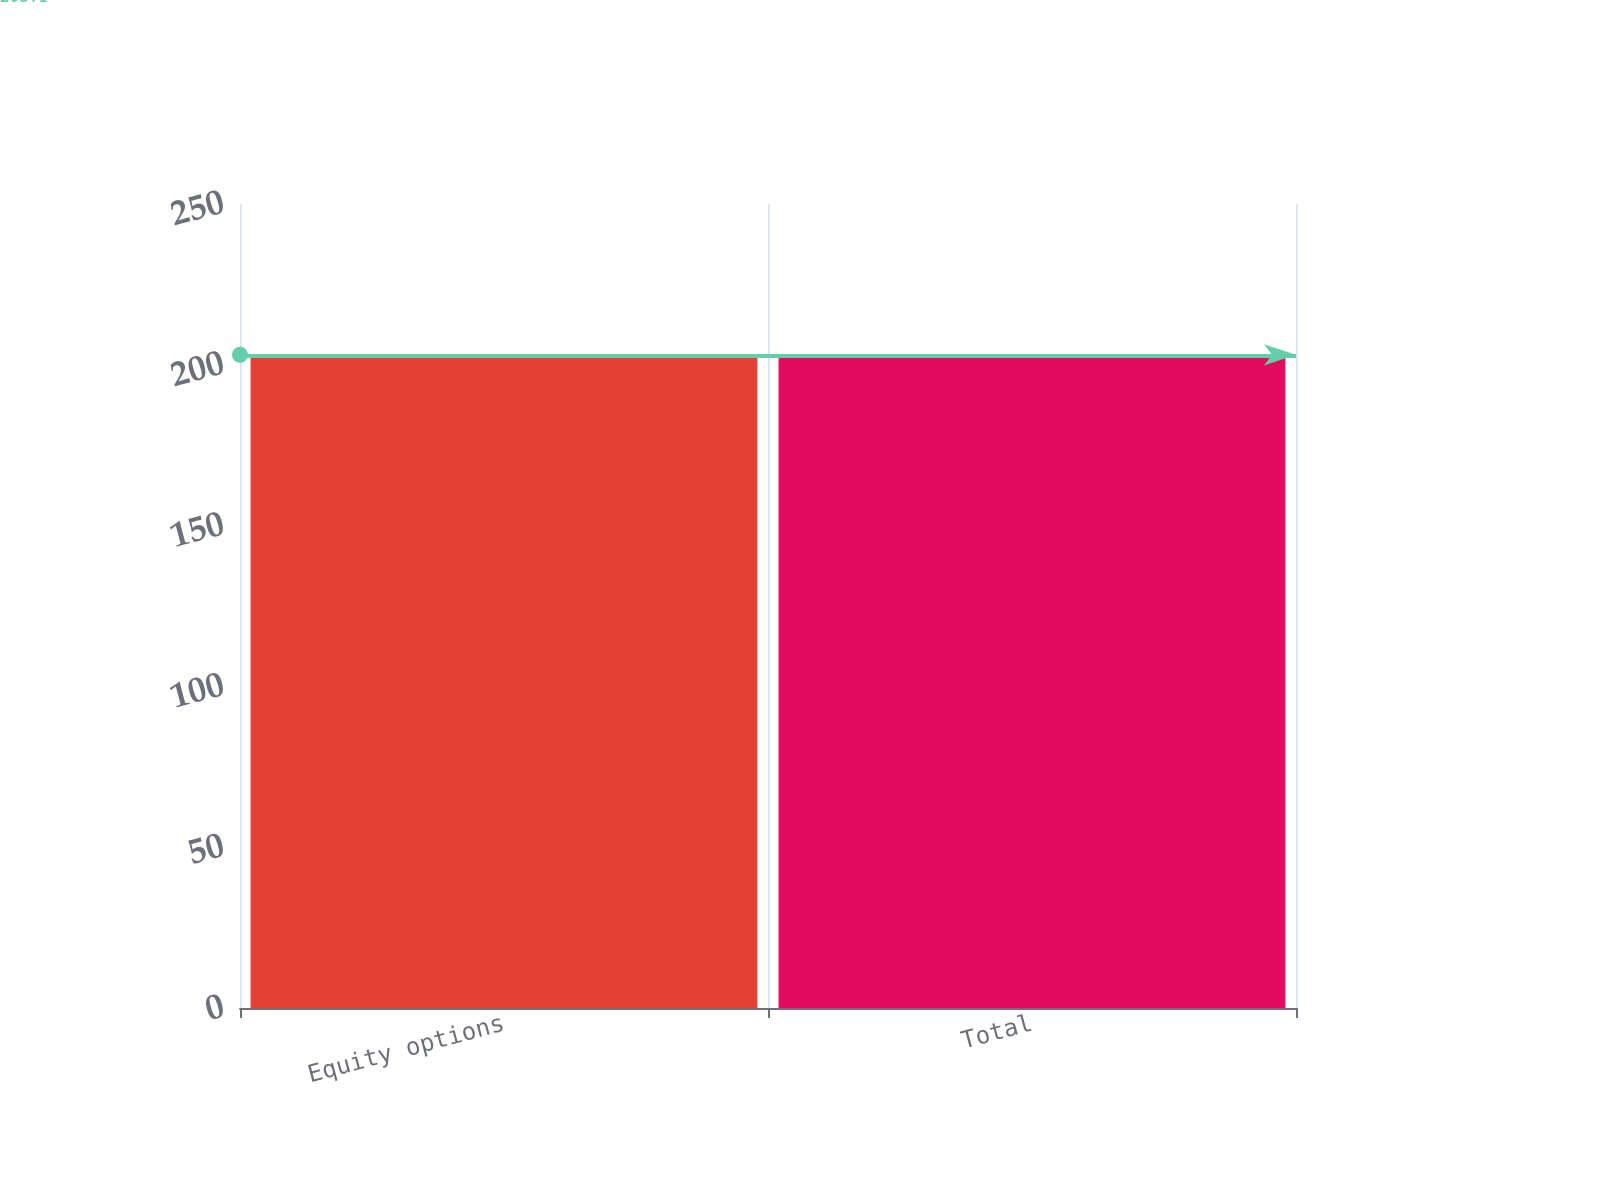Convert chart to OTSL. <chart><loc_0><loc_0><loc_500><loc_500><bar_chart><fcel>Equity options<fcel>Total<nl><fcel>203<fcel>203.1<nl></chart> 